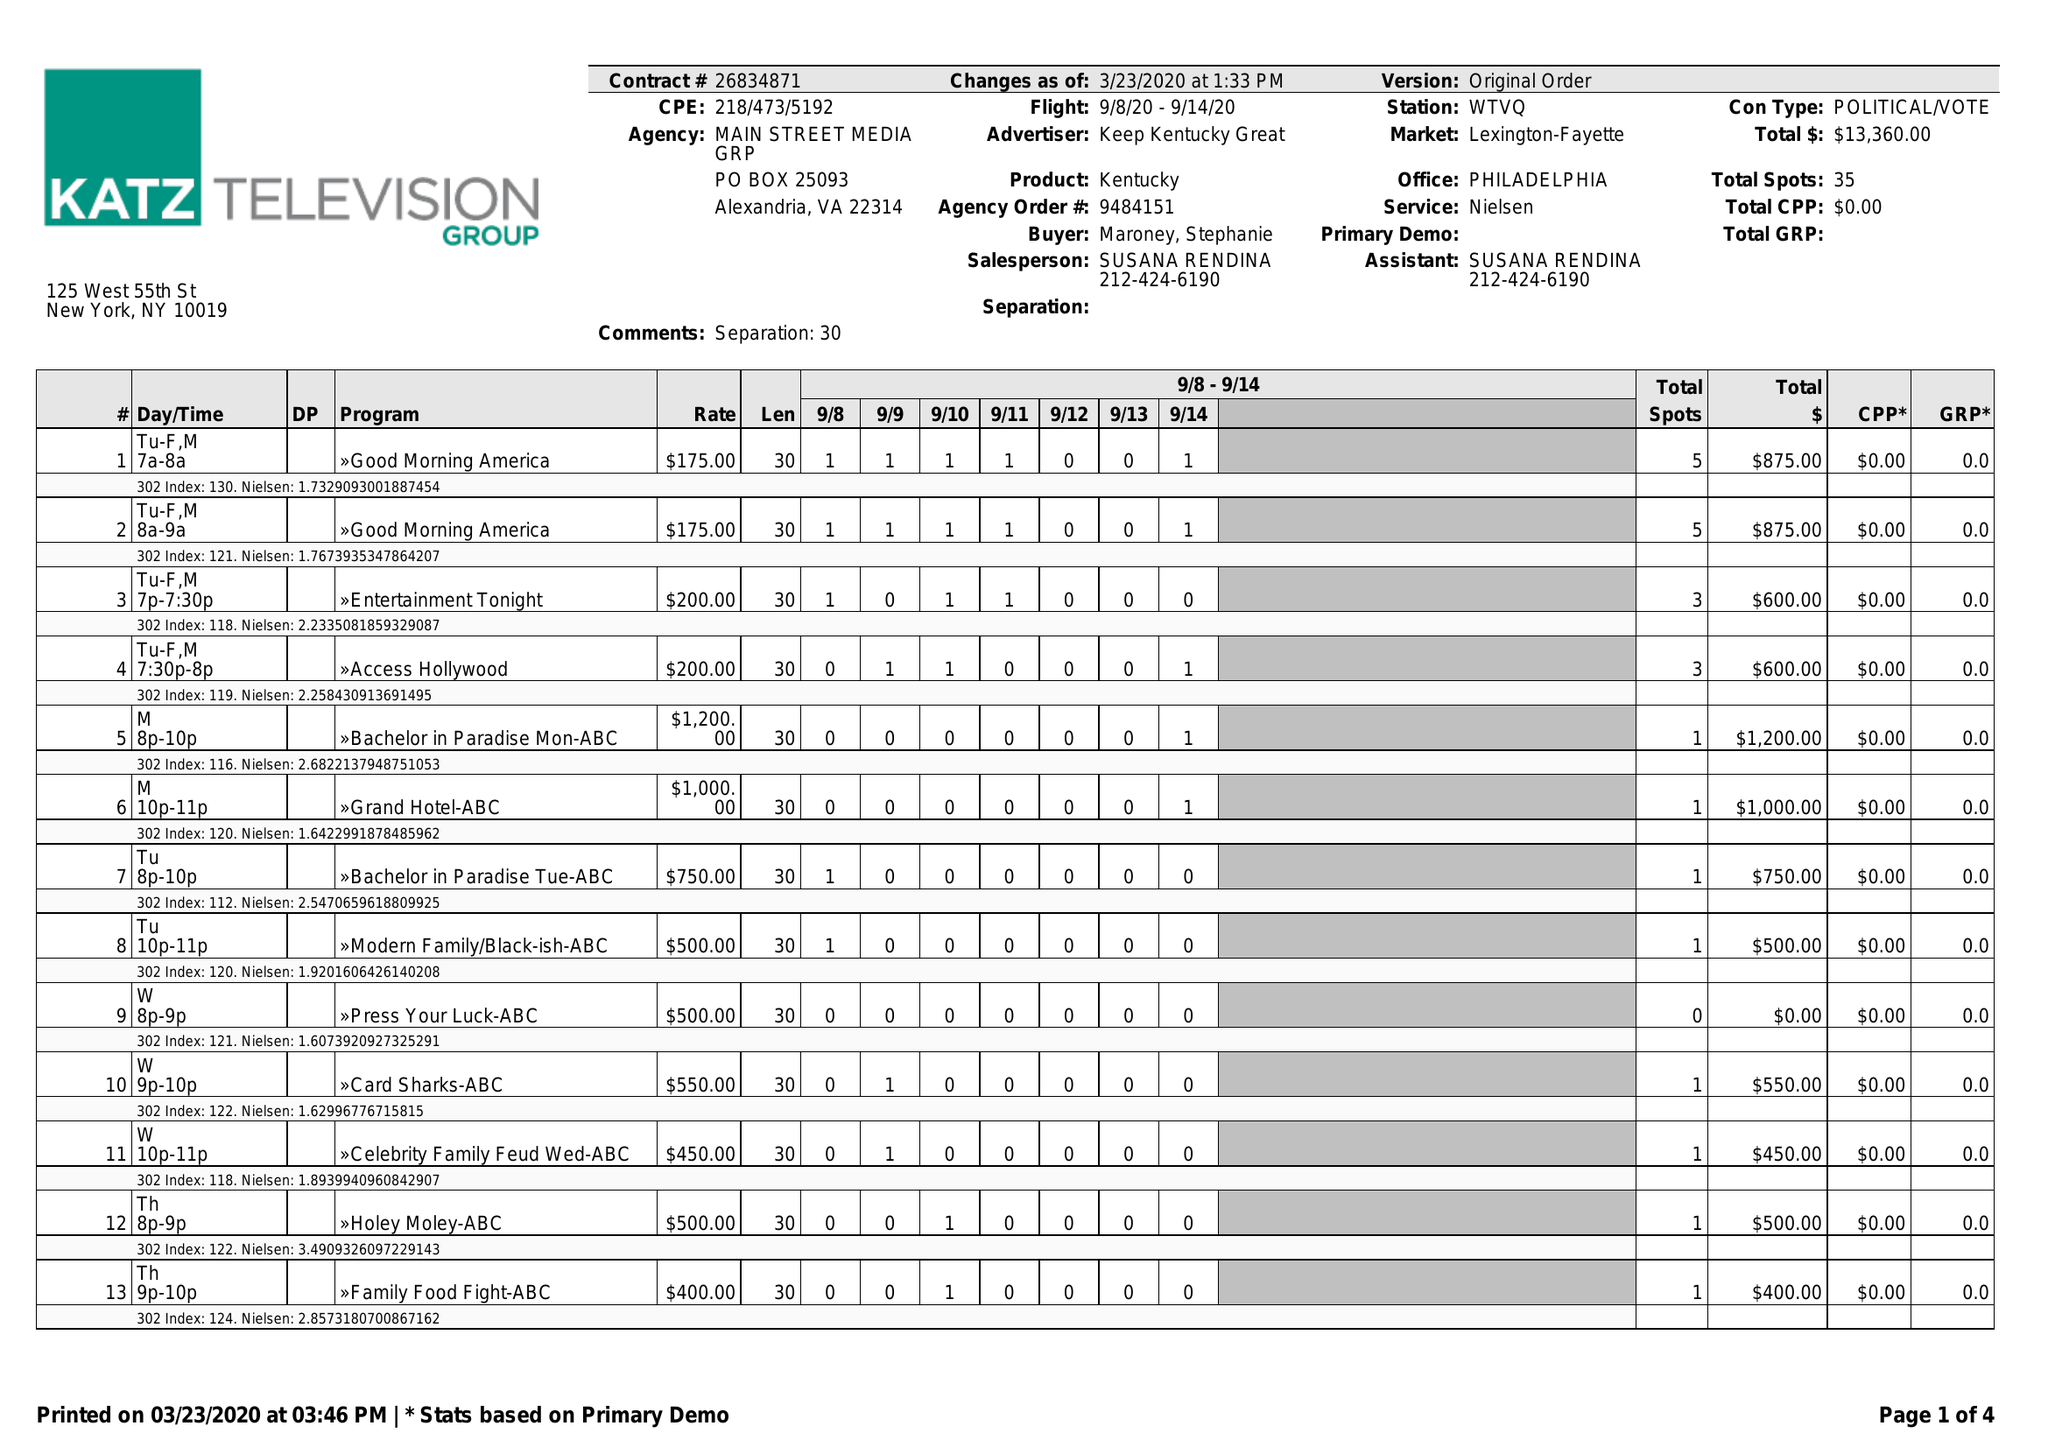What is the value for the flight_from?
Answer the question using a single word or phrase. 09/08/20 